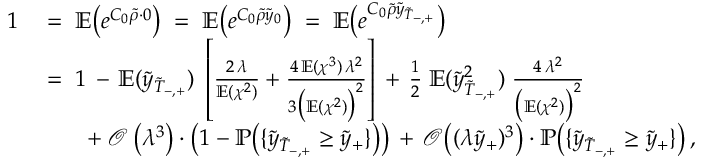Convert formula to latex. <formula><loc_0><loc_0><loc_500><loc_500>\begin{array} { r l } { 1 } & { \, = \, \mathbb { E } \left ( e ^ { C _ { 0 } \widetilde { \rho } \cdot 0 } \right ) \, = \, \mathbb { E } \left ( e ^ { C _ { 0 } \widetilde { \rho } \widetilde { y } _ { 0 } } \right ) \, = \, \mathbb { E } \left ( e ^ { C _ { 0 } \widetilde { \rho } \widetilde { y } _ { \widetilde { T } _ { - , + } } } \right ) } \\ & { \, = \, 1 \, - \, \mathbb { E } ( \widetilde { y } _ { \widetilde { T } _ { - , + } } ) \, \left [ \frac { 2 \, \lambda } { \mathbb { E } ( \chi ^ { 2 } ) } + \frac { 4 \, \mathbb { E } ( \chi ^ { 3 } ) \, \lambda ^ { 2 } } { 3 \left ( \mathbb { E } ( \chi ^ { 2 } ) \right ) ^ { 2 } } \right ] \, + \, \frac { 1 } { 2 } \, \mathbb { E } ( \widetilde { y } _ { \widetilde { T } _ { - , + } } ^ { 2 } ) \, \frac { 4 \, \lambda ^ { 2 } } { \left ( \mathbb { E } ( \chi ^ { 2 } ) \right ) ^ { 2 } } } \\ & { \quad + \, \mathcal { O } \left ( \lambda ^ { 3 } \right ) \cdot \left ( 1 - \mathbb { P } \left ( \{ \widetilde { y } _ { \widetilde { T } _ { - , + } } \geq \widetilde { y } _ { + } \} \right ) \right ) \, + \, \mathcal { O } \left ( ( \lambda \widetilde { y } _ { + } ) ^ { 3 } \right ) \cdot \mathbb { P } \left ( \{ \widetilde { y } _ { \widetilde { T } _ { - , + } } \geq \widetilde { y } _ { + } \} \right ) \, , } \end{array}</formula> 